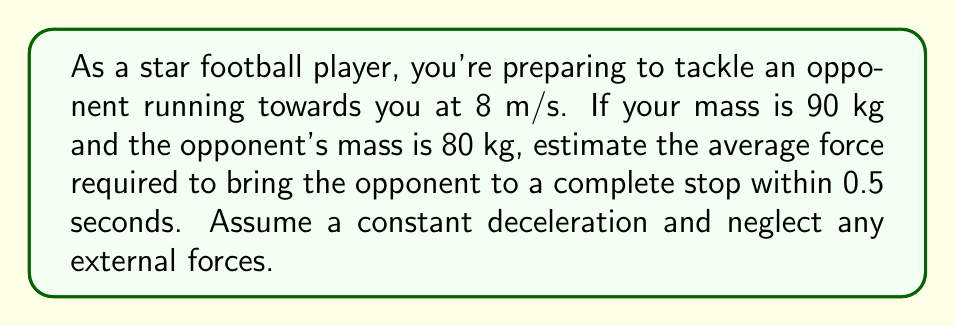Can you solve this math problem? To solve this problem, we'll use Newton's Second Law of Motion and the equations of motion for constant acceleration. Let's break it down step-by-step:

1) First, we need to calculate the deceleration of the opponent:
   Initial velocity $v_0 = 8$ m/s
   Final velocity $v = 0$ m/s (complete stop)
   Time $t = 0.5$ s
   
   Using the equation: $a = \frac{v - v_0}{t}$
   
   $a = \frac{0 - 8}{0.5} = -16$ m/s²

2) Now, we can use Newton's Second Law: $F = ma$
   Where $m$ is the mass of the opponent and $a$ is the acceleration (in this case, deceleration)

   $F = 80 \text{ kg} \times (-16 \text{ m/s²}) = -1280$ N

3) The negative sign indicates the force is in the opposite direction of the initial motion. The magnitude of the force is 1280 N.

4) However, this is the force experienced by the opponent. To find the force you need to exert, we need to consider the conservation of momentum:

   Your momentum change = Opponent's momentum change
   
   $90 \text{ kg} \times \Delta v_{\text{you}} = 80 \text{ kg} \times 8 \text{ m/s}$
   
   $\Delta v_{\text{you}} = \frac{80 \times 8}{90} = 7.11$ m/s

5) Your acceleration: $a_{\text{you}} = \frac{7.11}{0.5} = 14.22$ m/s²

6) Force you need to exert:
   $F_{\text{you}} = 90 \text{ kg} \times 14.22 \text{ m/s²} = 1280$ N

Therefore, the estimated average force required to tackle the opponent is 1280 N.
Answer: 1280 N 